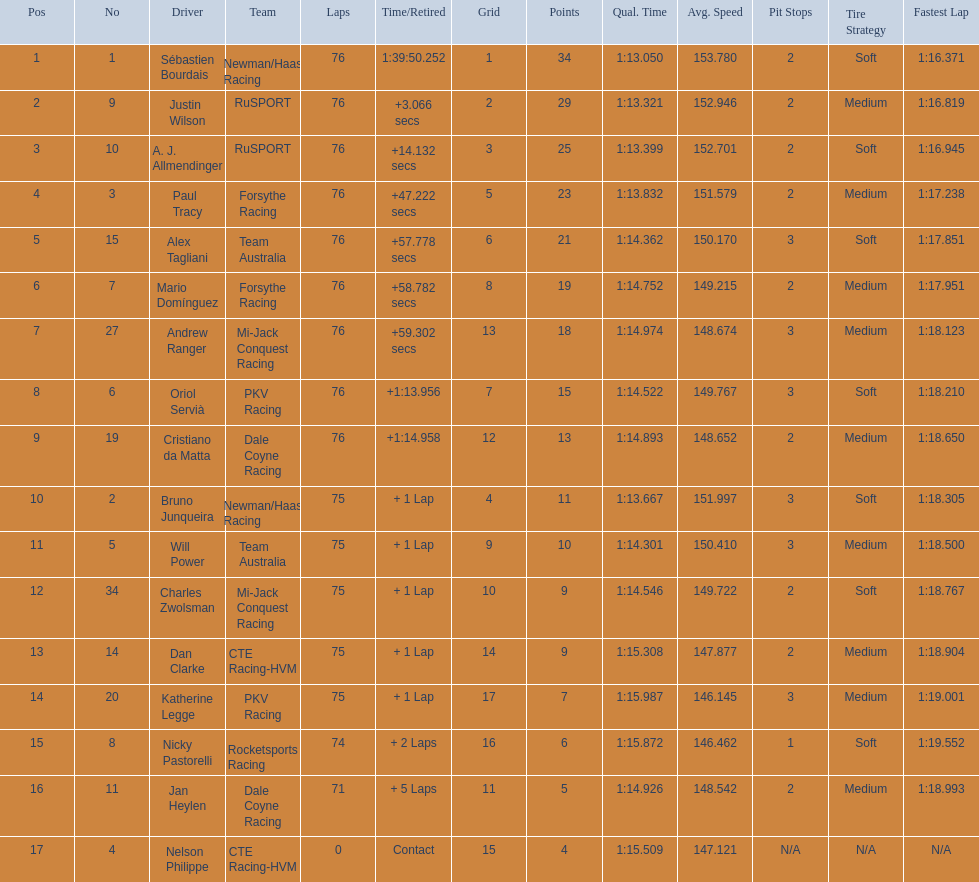Who drove during the 2006 tecate grand prix of monterrey? Sébastien Bourdais, Justin Wilson, A. J. Allmendinger, Paul Tracy, Alex Tagliani, Mario Domínguez, Andrew Ranger, Oriol Servià, Cristiano da Matta, Bruno Junqueira, Will Power, Charles Zwolsman, Dan Clarke, Katherine Legge, Nicky Pastorelli, Jan Heylen, Nelson Philippe. And what were their finishing positions? 1, 2, 3, 4, 5, 6, 7, 8, 9, 10, 11, 12, 13, 14, 15, 16, 17. Who did alex tagliani finish directly behind of? Paul Tracy. 